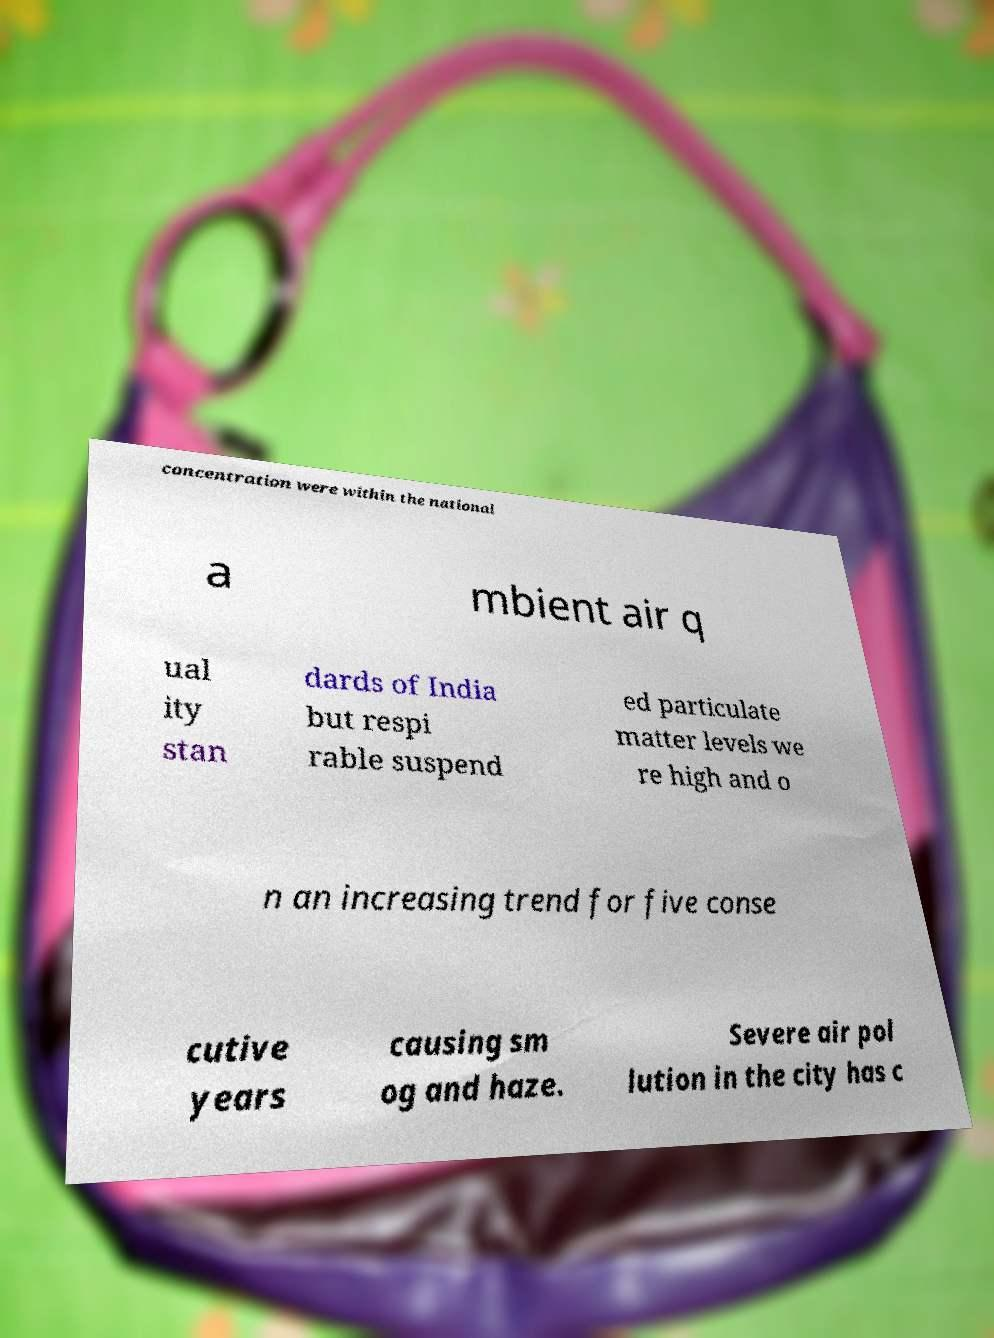Please identify and transcribe the text found in this image. concentration were within the national a mbient air q ual ity stan dards of India but respi rable suspend ed particulate matter levels we re high and o n an increasing trend for five conse cutive years causing sm og and haze. Severe air pol lution in the city has c 